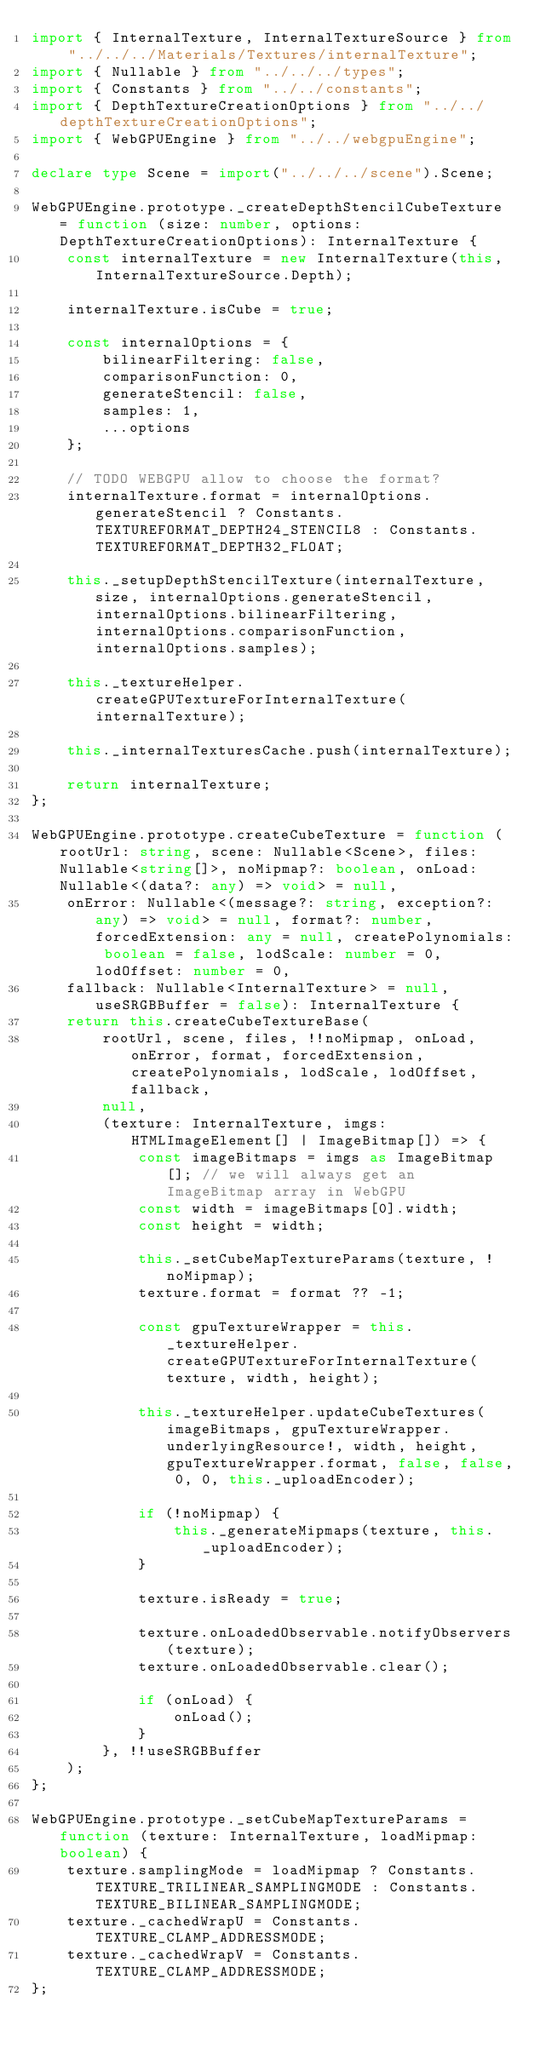Convert code to text. <code><loc_0><loc_0><loc_500><loc_500><_TypeScript_>import { InternalTexture, InternalTextureSource } from "../../../Materials/Textures/internalTexture";
import { Nullable } from "../../../types";
import { Constants } from "../../constants";
import { DepthTextureCreationOptions } from "../../depthTextureCreationOptions";
import { WebGPUEngine } from "../../webgpuEngine";

declare type Scene = import("../../../scene").Scene;

WebGPUEngine.prototype._createDepthStencilCubeTexture = function (size: number, options: DepthTextureCreationOptions): InternalTexture {
    const internalTexture = new InternalTexture(this, InternalTextureSource.Depth);

    internalTexture.isCube = true;

    const internalOptions = {
        bilinearFiltering: false,
        comparisonFunction: 0,
        generateStencil: false,
        samples: 1,
        ...options
    };

    // TODO WEBGPU allow to choose the format?
    internalTexture.format = internalOptions.generateStencil ? Constants.TEXTUREFORMAT_DEPTH24_STENCIL8 : Constants.TEXTUREFORMAT_DEPTH32_FLOAT;

    this._setupDepthStencilTexture(internalTexture, size, internalOptions.generateStencil, internalOptions.bilinearFiltering, internalOptions.comparisonFunction, internalOptions.samples);

    this._textureHelper.createGPUTextureForInternalTexture(internalTexture);

    this._internalTexturesCache.push(internalTexture);

    return internalTexture;
};

WebGPUEngine.prototype.createCubeTexture = function (rootUrl: string, scene: Nullable<Scene>, files: Nullable<string[]>, noMipmap?: boolean, onLoad: Nullable<(data?: any) => void> = null,
    onError: Nullable<(message?: string, exception?: any) => void> = null, format?: number, forcedExtension: any = null, createPolynomials: boolean = false, lodScale: number = 0, lodOffset: number = 0,
    fallback: Nullable<InternalTexture> = null, useSRGBBuffer = false): InternalTexture {
    return this.createCubeTextureBase(
        rootUrl, scene, files, !!noMipmap, onLoad, onError, format, forcedExtension, createPolynomials, lodScale, lodOffset, fallback,
        null,
        (texture: InternalTexture, imgs: HTMLImageElement[] | ImageBitmap[]) => {
            const imageBitmaps = imgs as ImageBitmap[]; // we will always get an ImageBitmap array in WebGPU
            const width = imageBitmaps[0].width;
            const height = width;

            this._setCubeMapTextureParams(texture, !noMipmap);
            texture.format = format ?? -1;

            const gpuTextureWrapper = this._textureHelper.createGPUTextureForInternalTexture(texture, width, height);

            this._textureHelper.updateCubeTextures(imageBitmaps, gpuTextureWrapper.underlyingResource!, width, height, gpuTextureWrapper.format, false, false, 0, 0, this._uploadEncoder);

            if (!noMipmap) {
                this._generateMipmaps(texture, this._uploadEncoder);
            }

            texture.isReady = true;

            texture.onLoadedObservable.notifyObservers(texture);
            texture.onLoadedObservable.clear();

            if (onLoad) {
                onLoad();
            }
        }, !!useSRGBBuffer
    );
};

WebGPUEngine.prototype._setCubeMapTextureParams = function (texture: InternalTexture, loadMipmap: boolean) {
    texture.samplingMode = loadMipmap ? Constants.TEXTURE_TRILINEAR_SAMPLINGMODE : Constants.TEXTURE_BILINEAR_SAMPLINGMODE;
    texture._cachedWrapU = Constants.TEXTURE_CLAMP_ADDRESSMODE;
    texture._cachedWrapV = Constants.TEXTURE_CLAMP_ADDRESSMODE;
};
</code> 